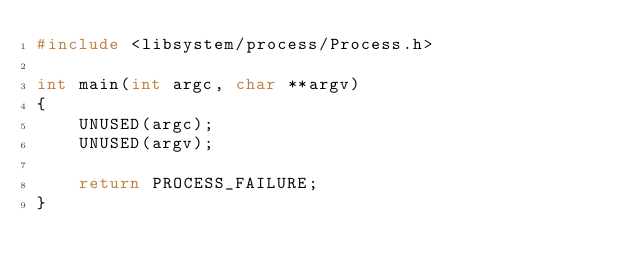Convert code to text. <code><loc_0><loc_0><loc_500><loc_500><_C++_>#include <libsystem/process/Process.h>

int main(int argc, char **argv)
{
    UNUSED(argc);
    UNUSED(argv);

    return PROCESS_FAILURE;
}
</code> 